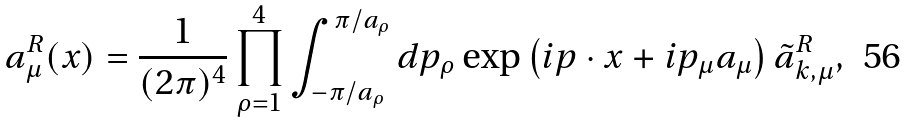Convert formula to latex. <formula><loc_0><loc_0><loc_500><loc_500>a _ { \mu } ^ { R } ( x ) = \frac { 1 } { ( 2 \pi ) ^ { 4 } } \prod _ { \rho = 1 } ^ { 4 } \int _ { - \pi / a _ { \rho } } ^ { \pi / a _ { \rho } } d p _ { \rho } \exp \left ( i p \cdot x + i p _ { \mu } a _ { \mu } \right ) \tilde { a } _ { k , \mu } ^ { R } ,</formula> 